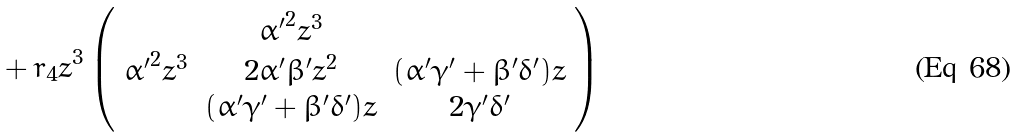Convert formula to latex. <formula><loc_0><loc_0><loc_500><loc_500>\, + \, r _ { 4 } z ^ { 3 } \left ( \begin{array} { c c c } & { \alpha ^ { \prime } } ^ { 2 } z ^ { 3 } & \\ { \alpha ^ { \prime } } ^ { 2 } z ^ { 3 } & 2 { \alpha ^ { \prime } } { \beta ^ { \prime } } z ^ { 2 } & ( { \alpha ^ { \prime } } { \gamma ^ { \prime } } + { \beta ^ { \prime } } { \delta ^ { \prime } } ) z \\ & ( { \alpha ^ { \prime } } { \gamma ^ { \prime } } + { \beta ^ { \prime } } { \delta ^ { \prime } } ) z & 2 { \gamma ^ { \prime } } { \delta ^ { \prime } } \\ \end{array} \right )</formula> 